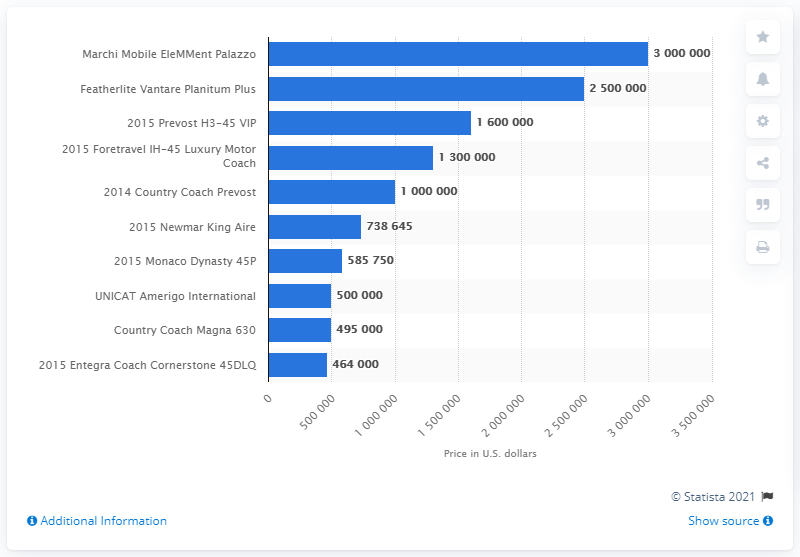Outline some significant characteristics in this image. The most expensive recreational vehicle is the Marchi Mobile EleMMent Palazzo. 